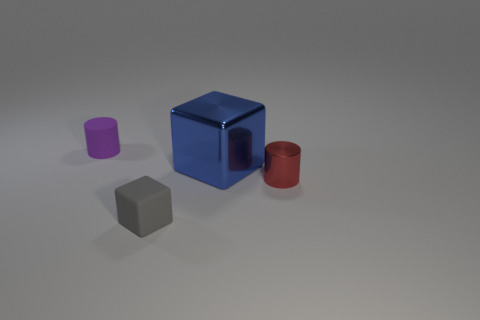How does the size of the red cylinder compare to the other shapes? The red cylinder is smaller than the blue cube but larger than both the purple cylinder and the small gray cube, illustrating the variety of sizes among the objects. 